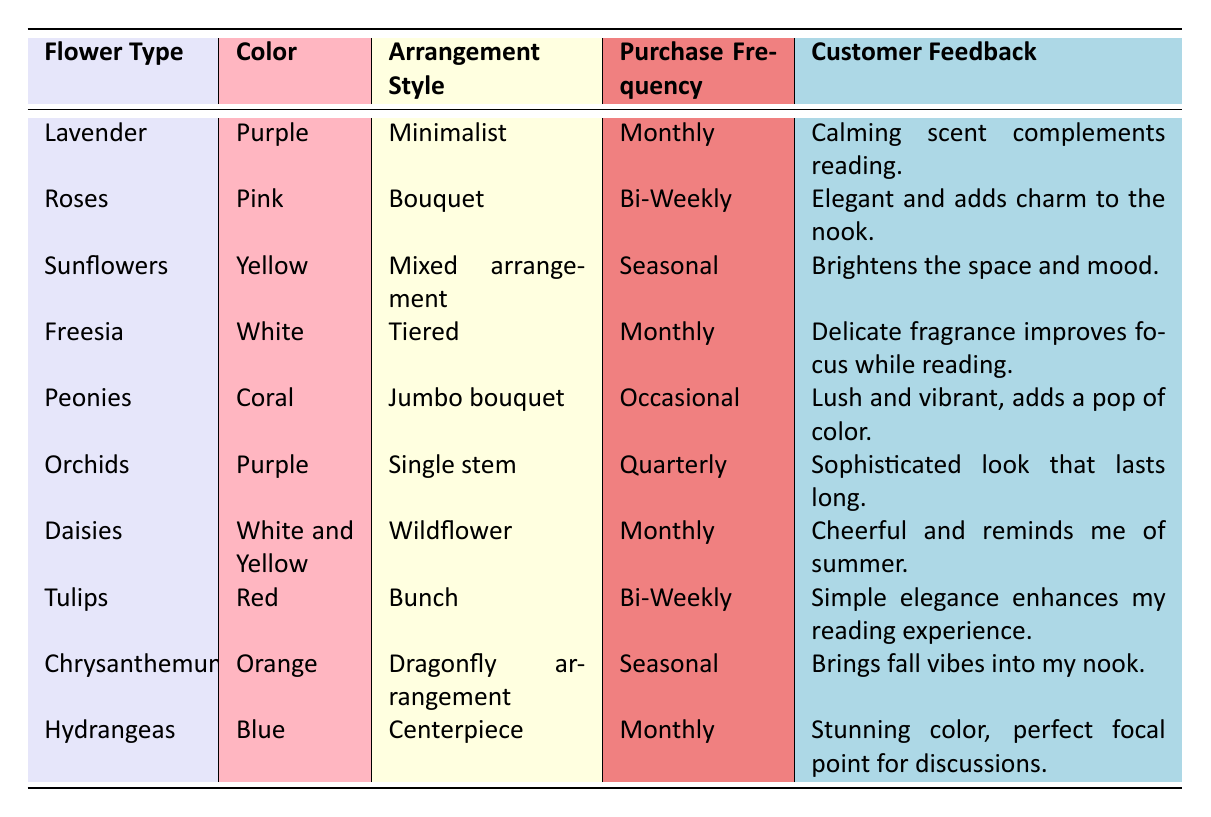What flower has a calming effect according to customer feedback? Customer feedback for Lavender states, "Calming scent complements reading." Therefore, Lavender has a calming effect.
Answer: Lavender Which flower type is purchased quarterly? The table lists Orchids under the "Purchase Frequency" column as being purchased "Quarterly."
Answer: Orchids How often are Daisies purchased? The frequency of purchase for Daisies is indicated as "Monthly."
Answer: Monthly Which flower type is associated with the color coral? The table shows Peonies associated with the color "Coral."
Answer: Peonies What arrangement style is most common for flowers purchased monthly? The arrangement styles for flowers with monthly purchase frequency are Minimalist (Lavender), Tiered (Freesia), Wildflower (Daisies), and Centerpiece (Hydrangeas). There are multiple styles, but Tiered is one of them.
Answer: Multiple styles How many flower types have a seasonal purchase frequency? The flowers labeled with "Seasonal" purchase frequency are Sunflowers and Chrysanthemums. So, there are 2 flower types.
Answer: 2 Which flower arrangement style is described as "Elegant" and what is the frequency of purchase? Roses are described as having an "Elegant" bouquet arrangement style, with a purchase frequency of "Bi-Weekly."
Answer: Bouquet, Bi-Weekly Do any flowers have a customer feedback indicating a focus on reading enhancement? Yes, Freesia has feedback stating, "Delicate fragrance improves focus while reading." This confirms the focus on reading enhancement.
Answer: Yes What is the unique characteristic of Orchids according to customer feedback? Orchids are described as having a "Sophisticated look that lasts long" in the customer feedback column, indicating their unique characteristic.
Answer: Sophisticated look How does the feedback for Sunflowers relate to customer mood? The feedback for Sunflowers states, "Brightens the space and mood," indicating that they enhance customer mood positively.
Answer: Brightens mood What is the difference in purchase frequency between the least and most frequently purchased flowers? The most frequently purchased flowers (Lavender, Freesia, Daisies, Hydrangeas) are all "Monthly," while the least (Orchids) are "Quarterly." Defining the purchase frequencies: Monthly = 1, Quarterly = 4; the difference is 3 months.
Answer: 3 months Which flower type received the most positive feedback regarding aesthetics? Peonies noted in the feedback as "Lush and vibrant, adds a pop of color," suggest that they received notably positive aesthetics feedback.
Answer: Peonies 